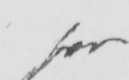What does this handwritten line say? for 